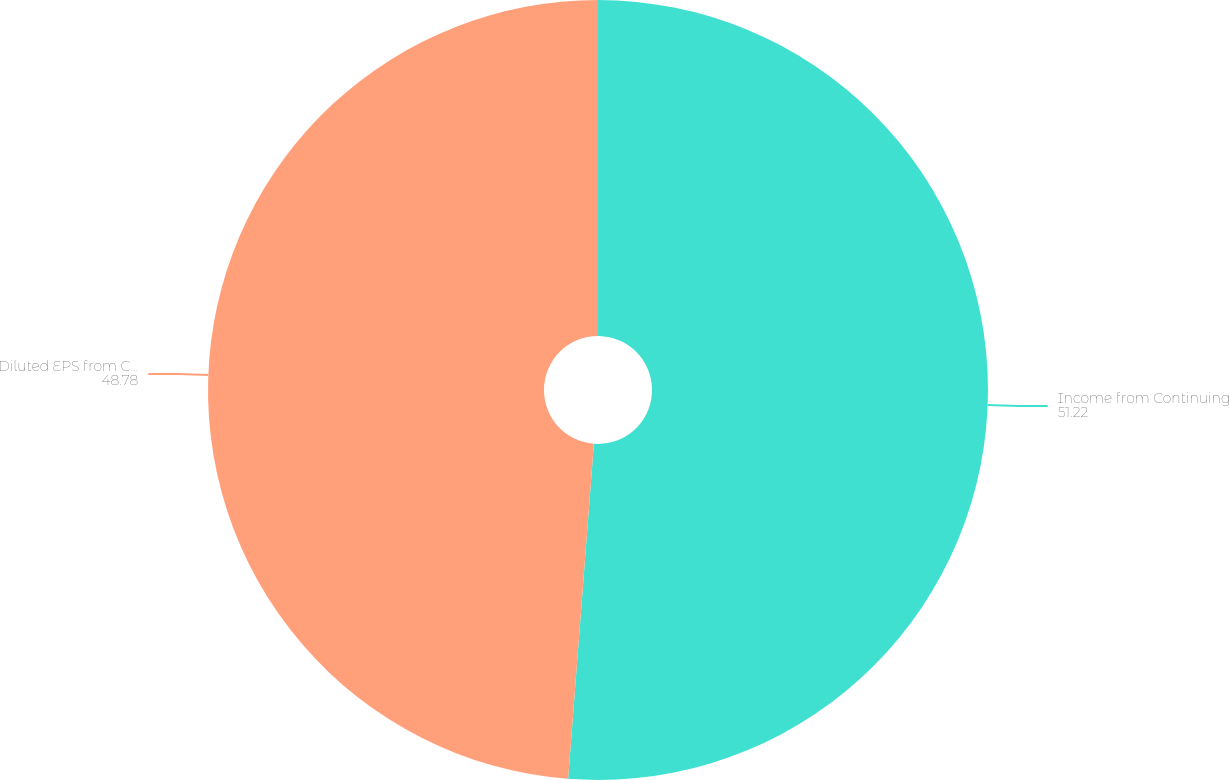Convert chart. <chart><loc_0><loc_0><loc_500><loc_500><pie_chart><fcel>Income from Continuing<fcel>Diluted EPS from Continuing<nl><fcel>51.22%<fcel>48.78%<nl></chart> 